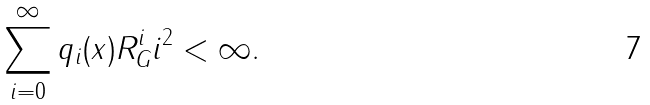Convert formula to latex. <formula><loc_0><loc_0><loc_500><loc_500>\sum _ { i = 0 } ^ { \infty } q _ { i } ( x ) R _ { G } ^ { i } i ^ { 2 } < \infty .</formula> 